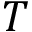<formula> <loc_0><loc_0><loc_500><loc_500>T</formula> 